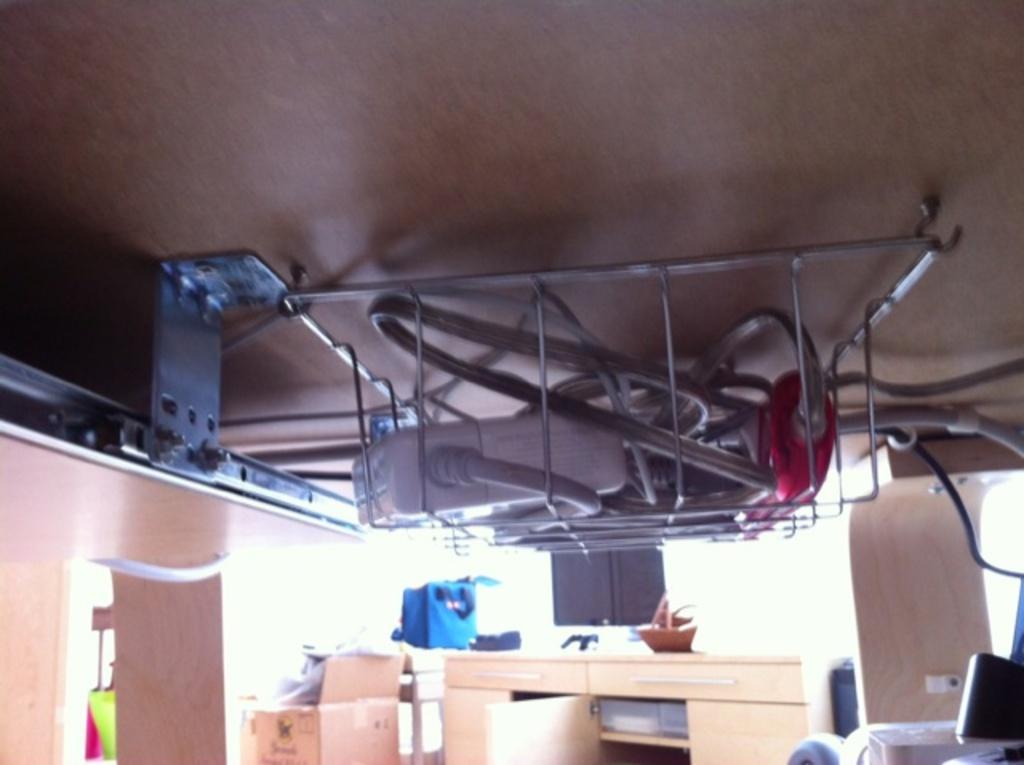Describe this image in one or two sentences. This is an inside picture of the room, in this image we can see some cartoon boxes, table and some other objects, at the top we can see an object, inside the object there are some things, in the background we can see the wall. 